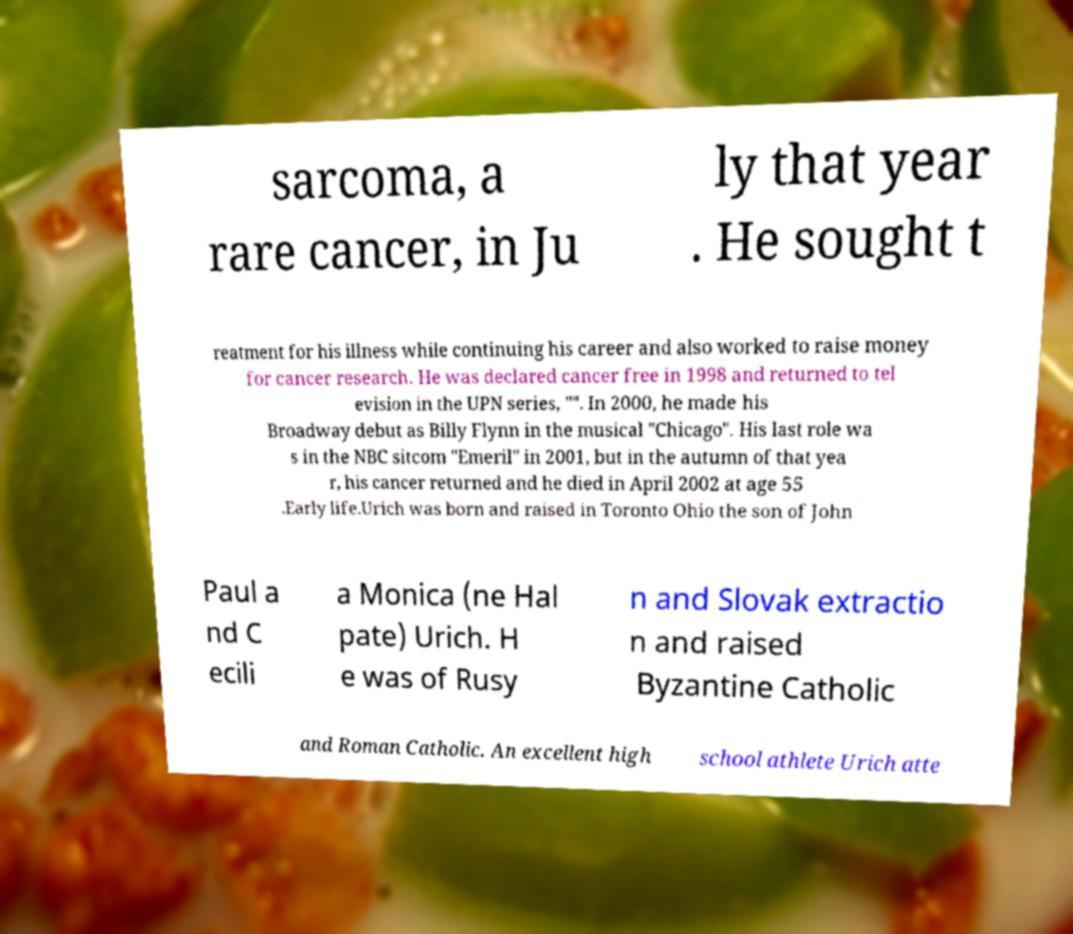Could you extract and type out the text from this image? sarcoma, a rare cancer, in Ju ly that year . He sought t reatment for his illness while continuing his career and also worked to raise money for cancer research. He was declared cancer free in 1998 and returned to tel evision in the UPN series, "". In 2000, he made his Broadway debut as Billy Flynn in the musical "Chicago". His last role wa s in the NBC sitcom "Emeril" in 2001, but in the autumn of that yea r, his cancer returned and he died in April 2002 at age 55 .Early life.Urich was born and raised in Toronto Ohio the son of John Paul a nd C ecili a Monica (ne Hal pate) Urich. H e was of Rusy n and Slovak extractio n and raised Byzantine Catholic and Roman Catholic. An excellent high school athlete Urich atte 